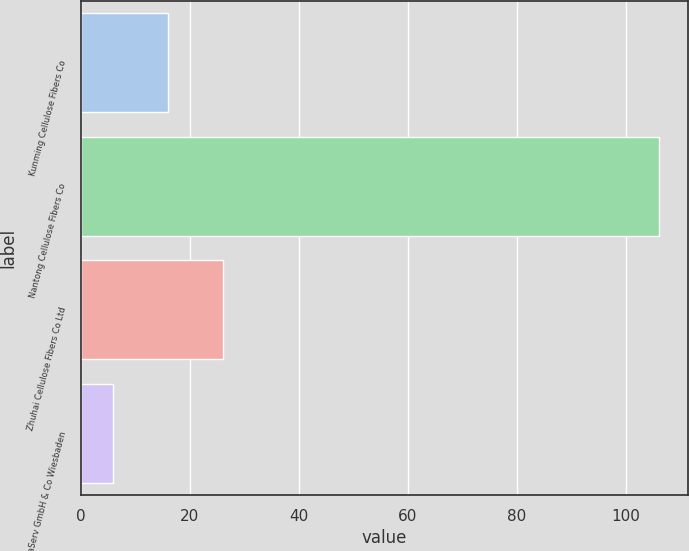Convert chart to OTSL. <chart><loc_0><loc_0><loc_500><loc_500><bar_chart><fcel>Kunming Cellulose Fibers Co<fcel>Nantong Cellulose Fibers Co<fcel>Zhuhai Cellulose Fibers Co Ltd<fcel>InfraServ GmbH & Co Wiesbaden<nl><fcel>16<fcel>106<fcel>26<fcel>6<nl></chart> 